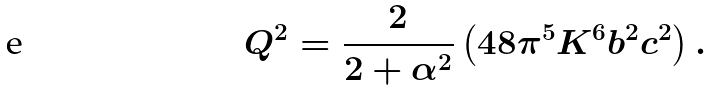Convert formula to latex. <formula><loc_0><loc_0><loc_500><loc_500>Q ^ { 2 } = \frac { 2 } { 2 + \alpha ^ { 2 } } \left ( 4 8 \pi ^ { 5 } K ^ { 6 } b ^ { 2 } c ^ { 2 } \right ) .</formula> 